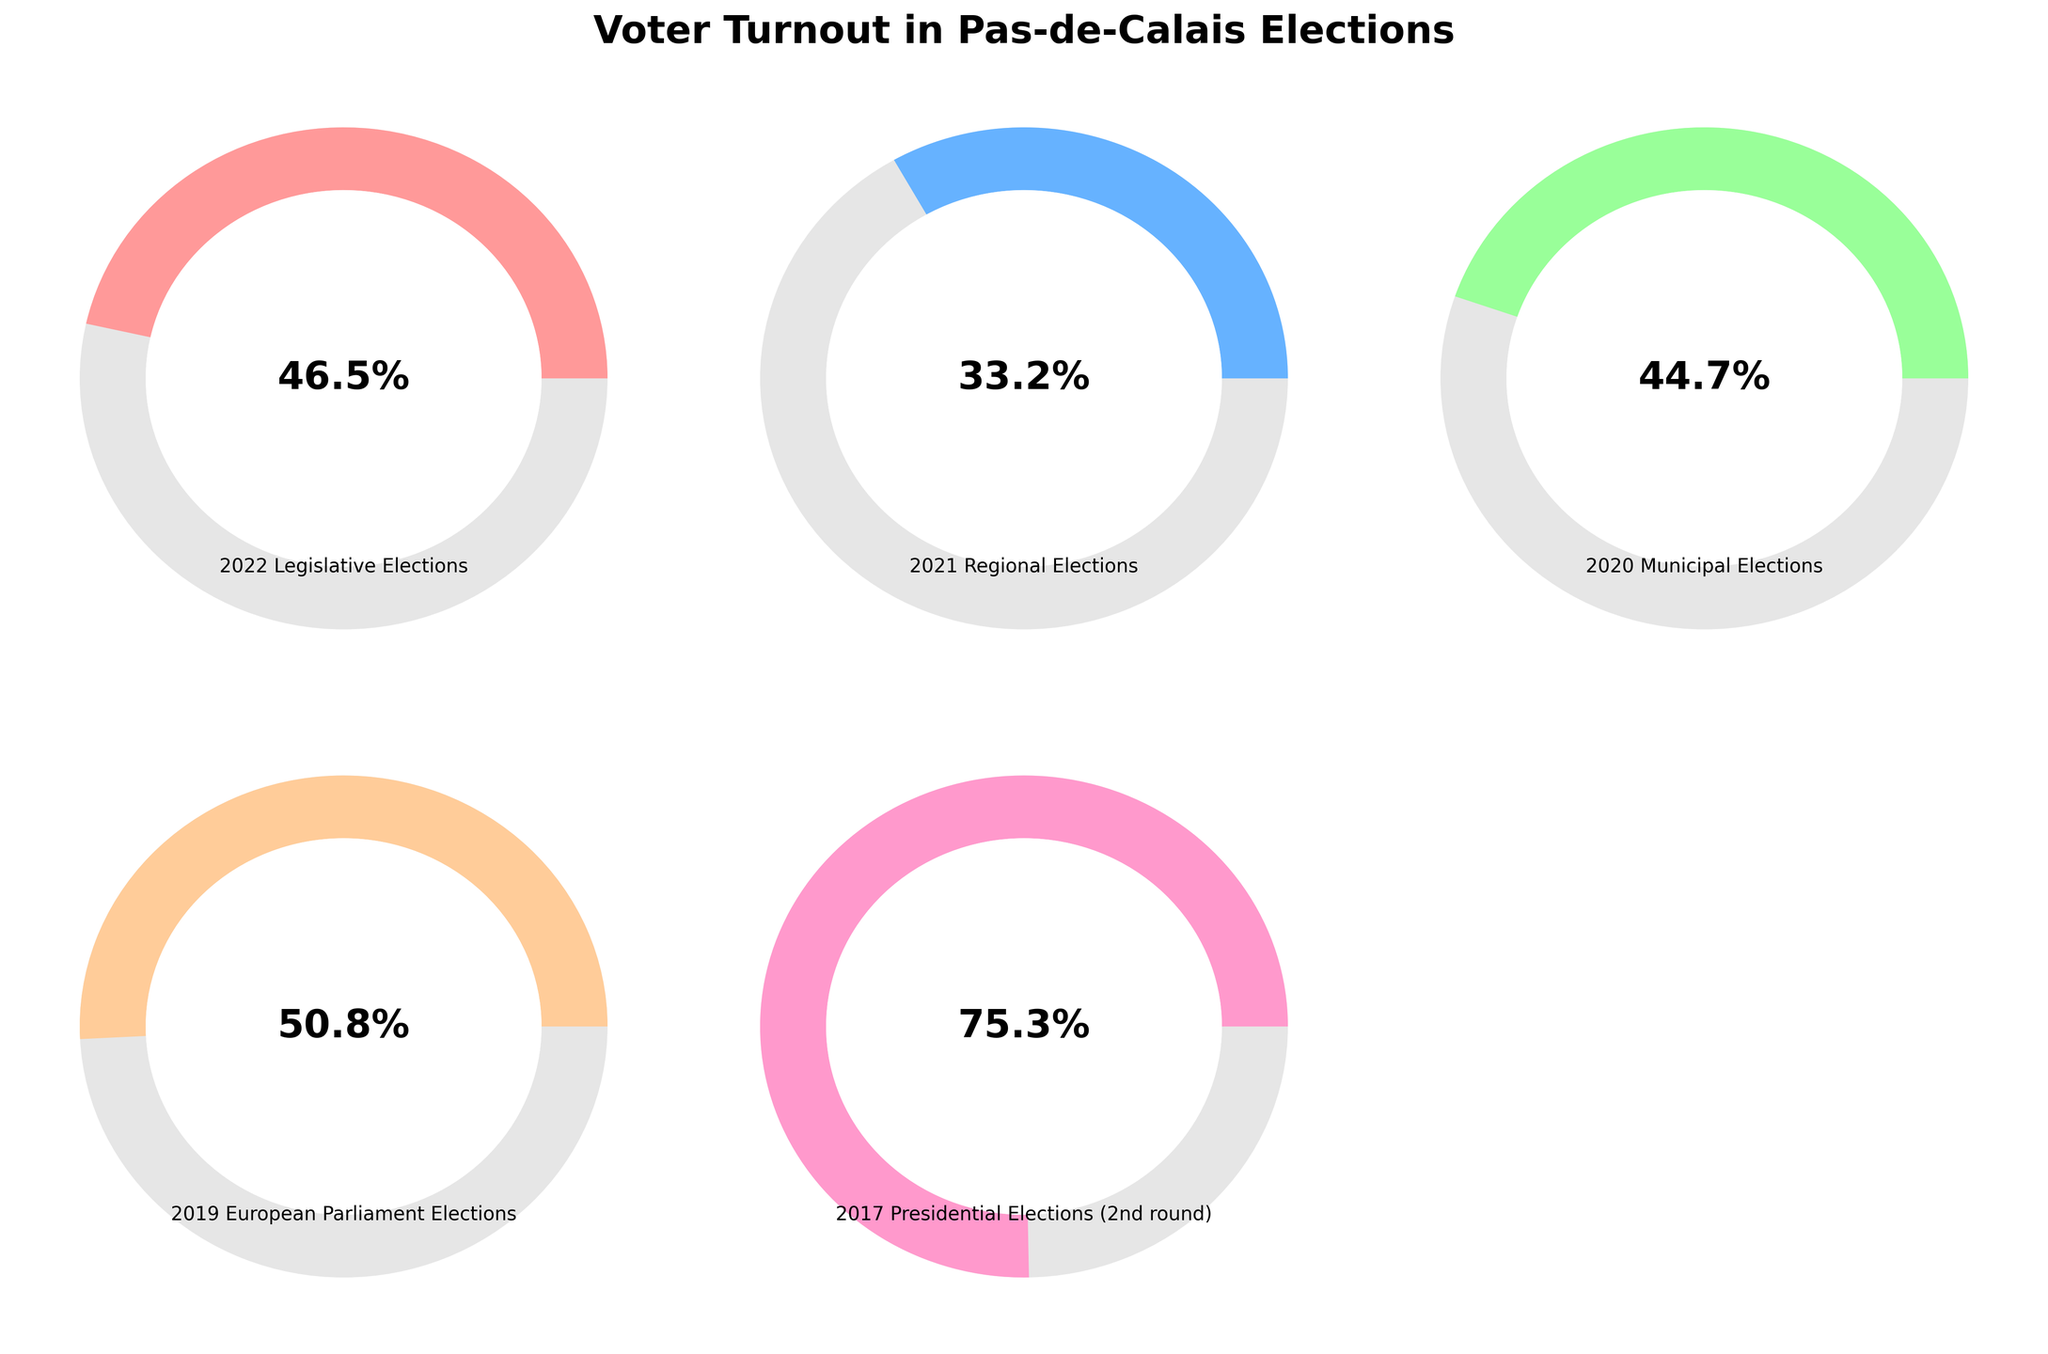What is the title of the figure? The title of the figure is shown at the top and reads "Voter Turnout in Pas-de-Calais Elections".
Answer: Voter Turnout in Pas-de-Calais Elections How many elections are represented in the figure? There are five elections represented in the figure, each with its turnout percentage.
Answer: Five Which election had the highest voter turnout percentage? By observing the percentages displayed on each gauge, the highest voter turnout percentage is 75.3% in the 2017 Presidential Elections (2nd round).
Answer: 2017 Presidential Elections (2nd round) Which election had the lowest voter turnout percentage? By observing the percentages displayed on each gauge, the lowest voter turnout percentage is 33.2% in the 2021 Regional Elections.
Answer: 2021 Regional Elections What is the difference in voter turnout percentage between the 2022 Legislative Elections and the 2021 Regional Elections? The voter turnout for the 2022 Legislative Elections is 46.5%, and for the 2021 Regional Elections is 33.2%. The difference is calculated as 46.5% - 33.2% = 13.3%.
Answer: 13.3% What is the average voter turnout percentage across all the elections? To calculate the average, sum the turnout percentages of all five elections (46.5 + 33.2 + 44.7 + 50.8 + 75.3) which equals 250.5, then divide by 5. The average is 250.5 / 5 = 50.1%.
Answer: 50.1% Is the voter turnout in the 2020 Municipal Elections greater than in the 2022 Legislative Elections? The voter turnout in the 2020 Municipal Elections is 44.7%, and in the 2022 Legislative Elections is 46.5%. 44.7% is not greater than 46.5%.
Answer: No Which election had a turnout percentage closest to 50%? By observing the percentages displayed on each gauge, the election with a turnout closest to 50% is the 2019 European Parliament Elections with a turnout of 50.8%.
Answer: 2019 European Parliament Elections How much greater is the voter turnout in the 2019 European Parliament Elections compared to the 2021 Regional Elections? The voter turnout in the 2019 European Parliament Elections is 50.8% and in the 2021 Regional Elections is 33.2%. The difference is calculated as 50.8% - 33.2% = 17.6%.
Answer: 17.6% 